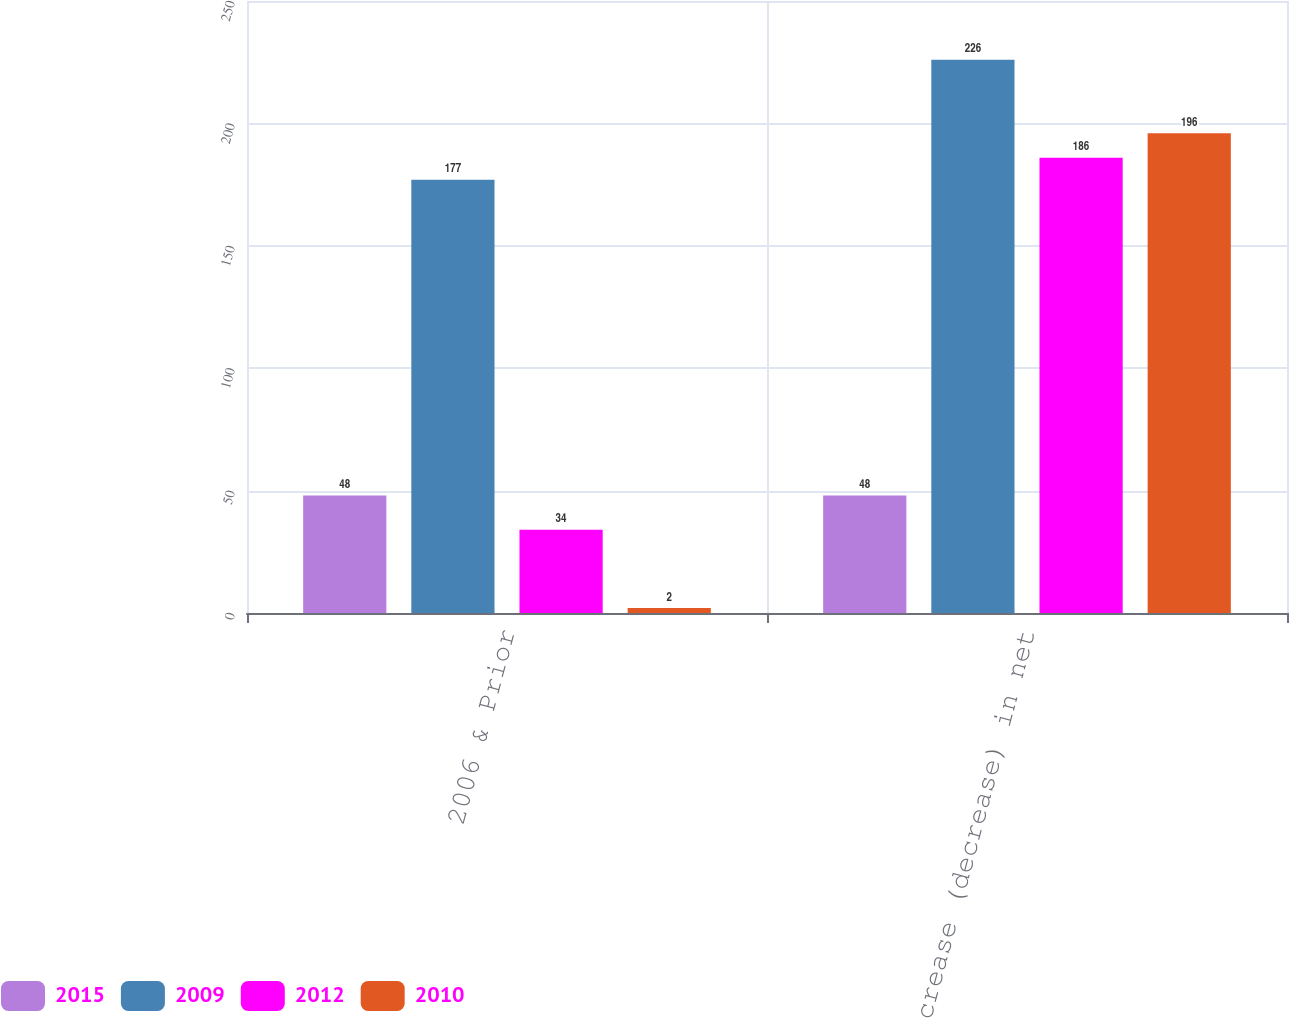<chart> <loc_0><loc_0><loc_500><loc_500><stacked_bar_chart><ecel><fcel>2006 & Prior<fcel>Increase (decrease) in net<nl><fcel>2015<fcel>48<fcel>48<nl><fcel>2009<fcel>177<fcel>226<nl><fcel>2012<fcel>34<fcel>186<nl><fcel>2010<fcel>2<fcel>196<nl></chart> 